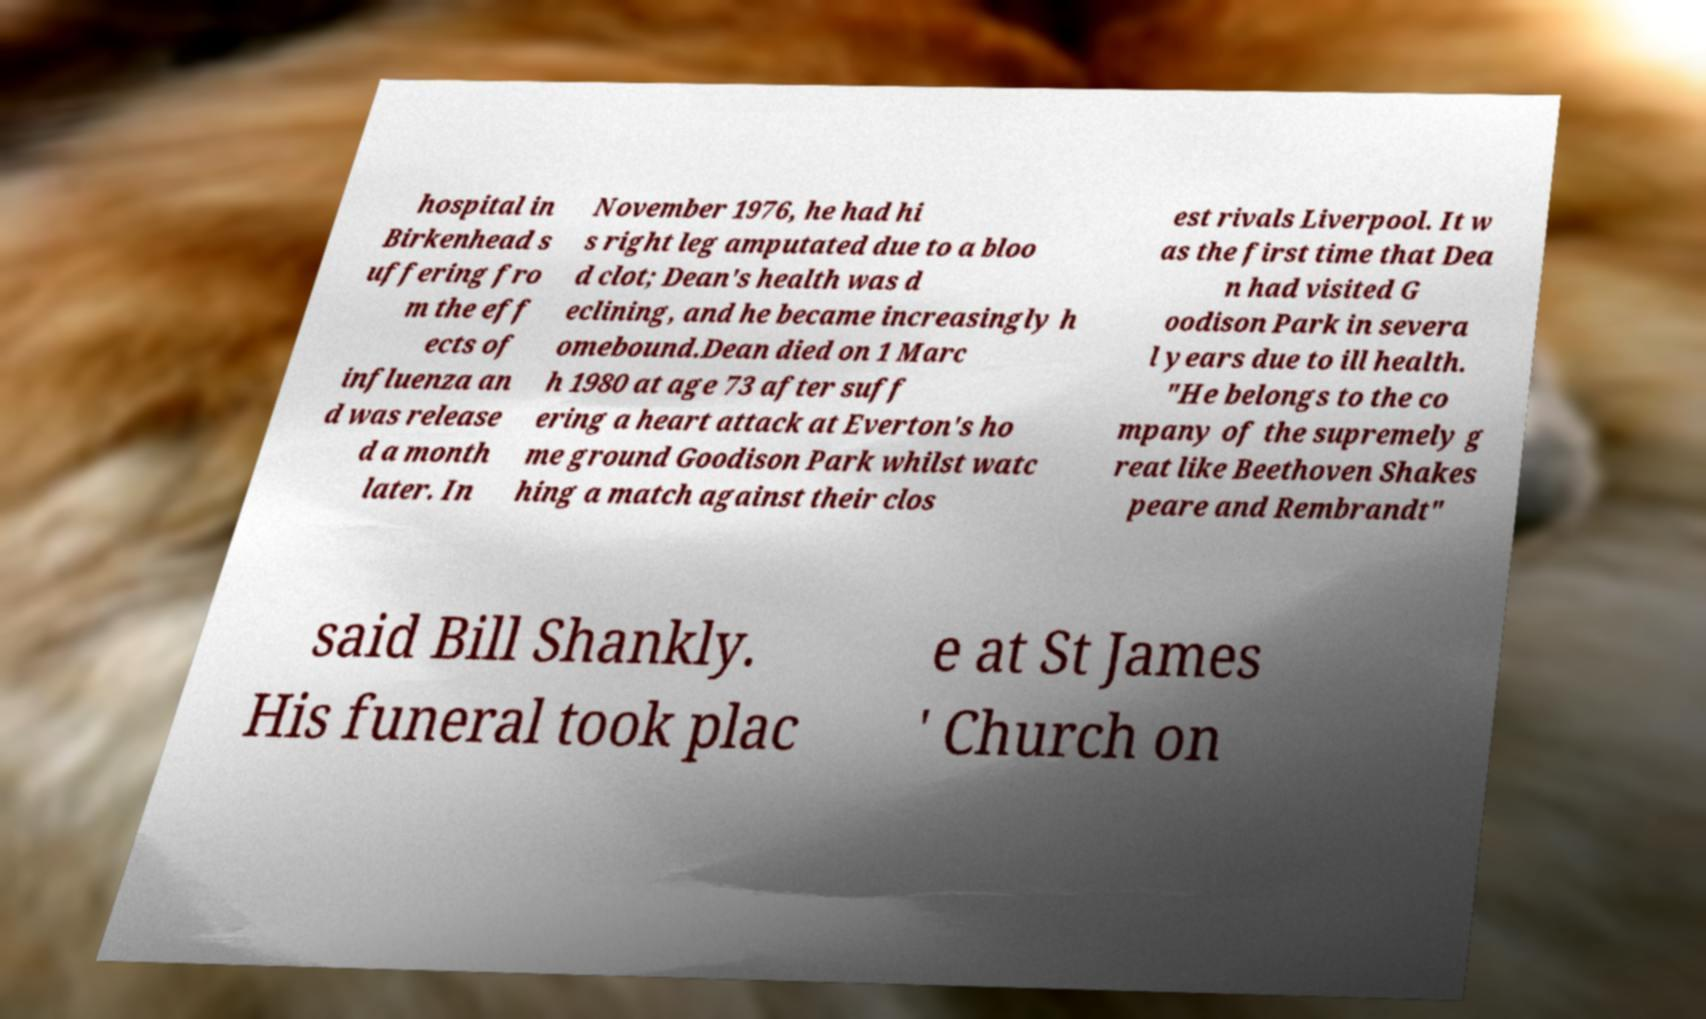Could you extract and type out the text from this image? hospital in Birkenhead s uffering fro m the eff ects of influenza an d was release d a month later. In November 1976, he had hi s right leg amputated due to a bloo d clot; Dean's health was d eclining, and he became increasingly h omebound.Dean died on 1 Marc h 1980 at age 73 after suff ering a heart attack at Everton's ho me ground Goodison Park whilst watc hing a match against their clos est rivals Liverpool. It w as the first time that Dea n had visited G oodison Park in severa l years due to ill health. "He belongs to the co mpany of the supremely g reat like Beethoven Shakes peare and Rembrandt" said Bill Shankly. His funeral took plac e at St James ' Church on 